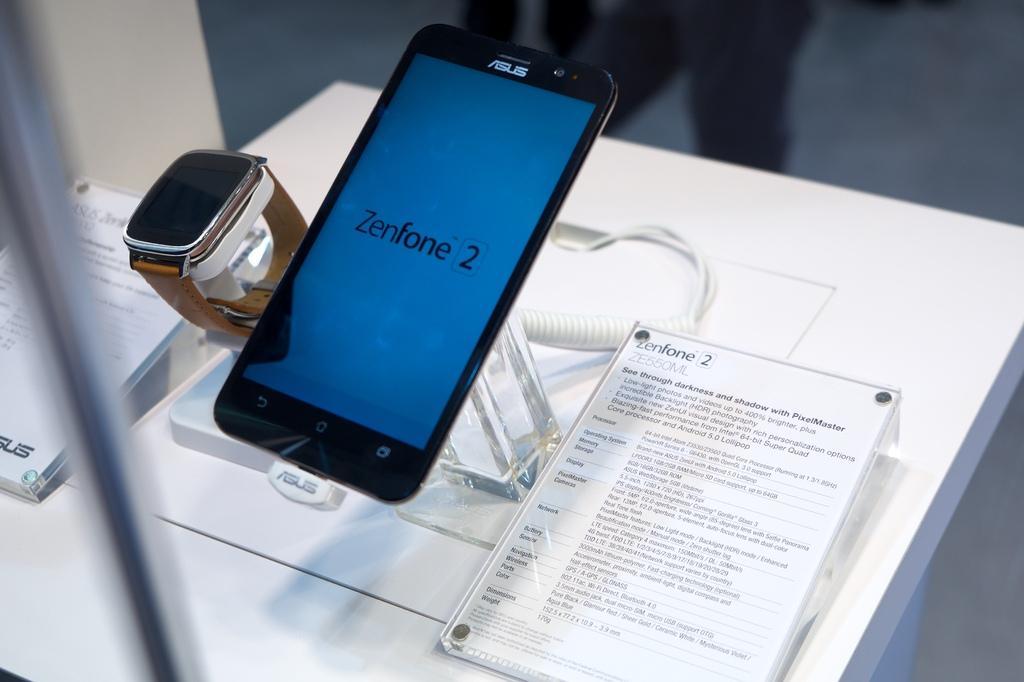Describe this image in one or two sentences. In this image we can see a mobile phone, watch and the two text boards, wire on the white color table. 